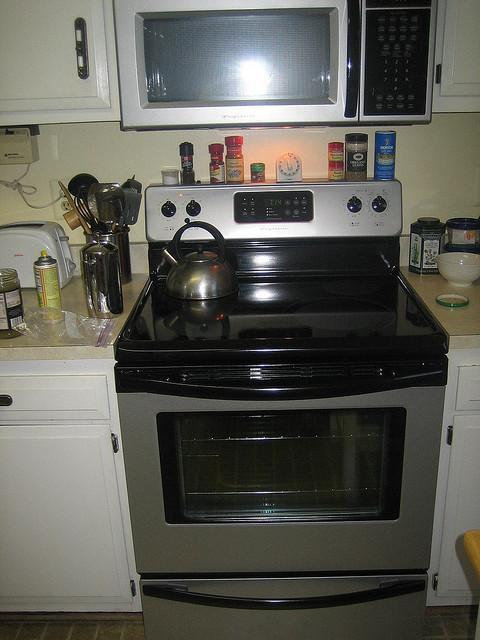How many people are reflected in the microwave window?
Give a very brief answer. 0. 